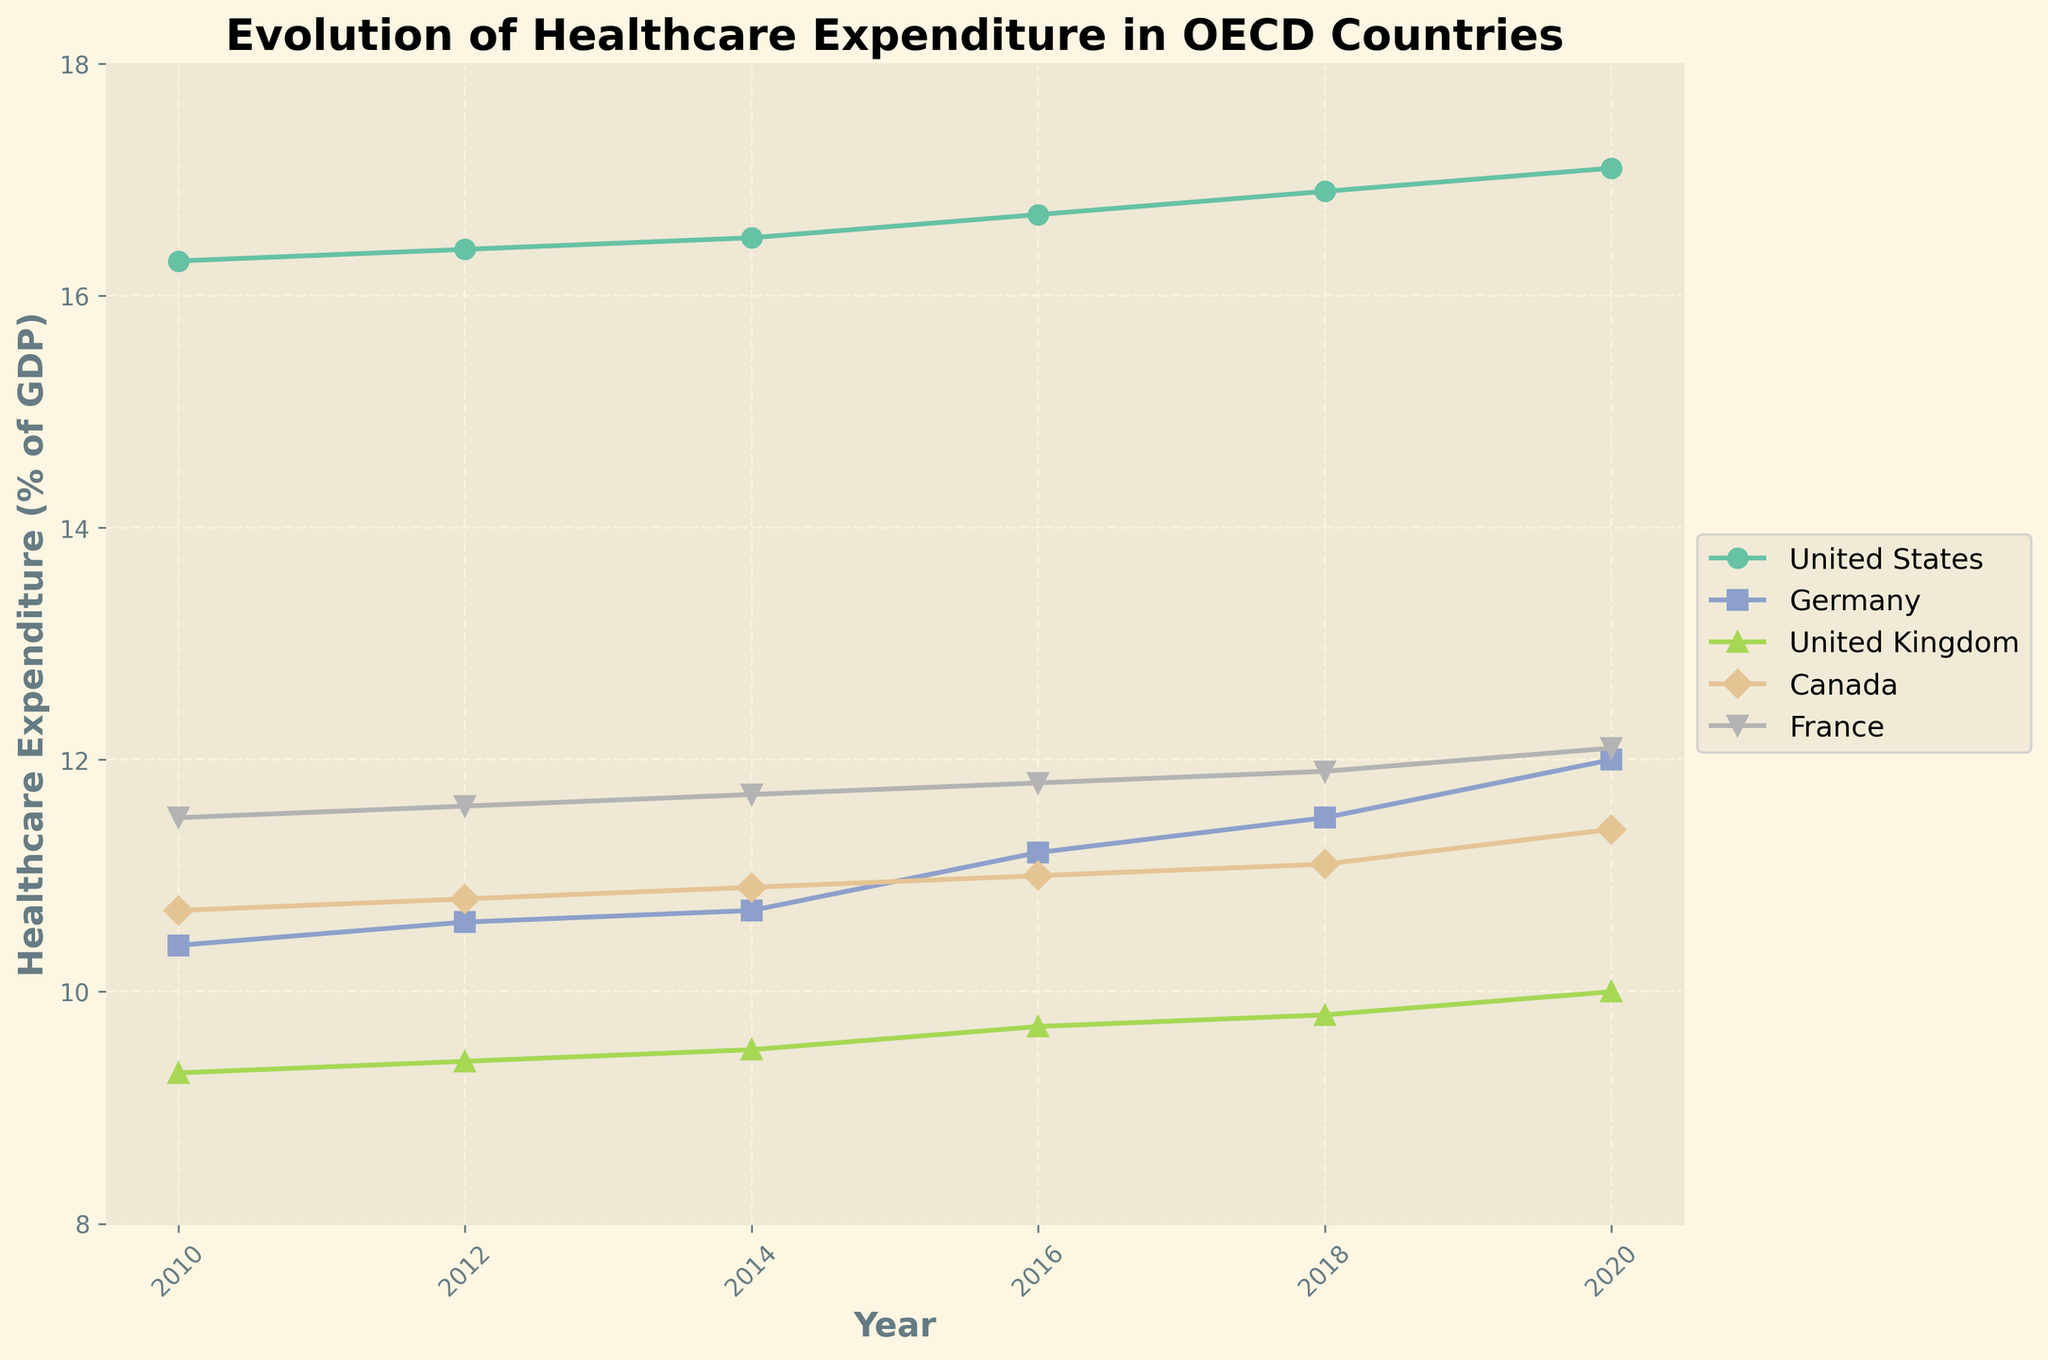What is the title of the figure? The title is displayed at the top of the figure in bold text. It is designed to give the viewer a quick understanding of what the figure represents.
Answer: Evolution of Healthcare Expenditure in OECD Countries How many countries are represented in the figure? The figure has a legend indicating the countries represented. Each country has a unique color and marker style in the legend and the plot. By counting these, we find the number of countries.
Answer: 5 Which country had the highest healthcare expenditure as a percentage of GDP in 2020? Locate the year 2020 on the x-axis and find the highest y-value for that year. United States has the highest point on the y-axis for the year 2020.
Answer: United States Did the United Kingdom's healthcare expenditure as a percentage of GDP increase or decrease from 2010 to 2020? Observe the line representing the United Kingdom from 2010 to 2020. The line shows an upward trend, indicating an increase.
Answer: Increase By how much did Germany's healthcare expenditure as a percentage of GDP change from 2016 to 2020? Find the points corresponding to Germany for 2016 and 2020, then subtract the 2016 value from the 2020 value (12.0 - 11.2).
Answer: 0.8 Which country saw the largest increase in healthcare expenditure as a percentage of GDP from 2010 to 2020? Calculate the increase for each country by subtracting the 2010 value from the 2020 value. The United States has the highest increase (17.1 - 16.3 = 0.8).
Answer: United States What was the average healthcare expenditure as a percentage of GDP for Canada between 2016 and 2020? Find the y-values for Canada between 2016 and 2020, sum them, and divide by the number of points: (11.0 + 11.1 + 11.4)/3 = 11.17.
Answer: 11.17 Which country had the most stable healthcare expenditure as a percentage of GDP from 2010 to 2020? Look for the country with the least fluctuations in its line. The United Kingdom has a relatively stable and linear increase compared to others.
Answer: United Kingdom Did any country decrease healthcare expenditure as a percentage of GDP from 2018 to 2020? Check the y-values for each country in 2018 and 2020. None of the countries show a decrease; all lines either remain the same or increase.
Answer: No What trends can be observed in the healthcare expenditure patterns across all represented countries from 2010 to 2020? All lines generally show an upward trend from 2010 to 2020, indicating increasing healthcare expenditure as a percentage of GDP across all countries.
Answer: Increasing trend 